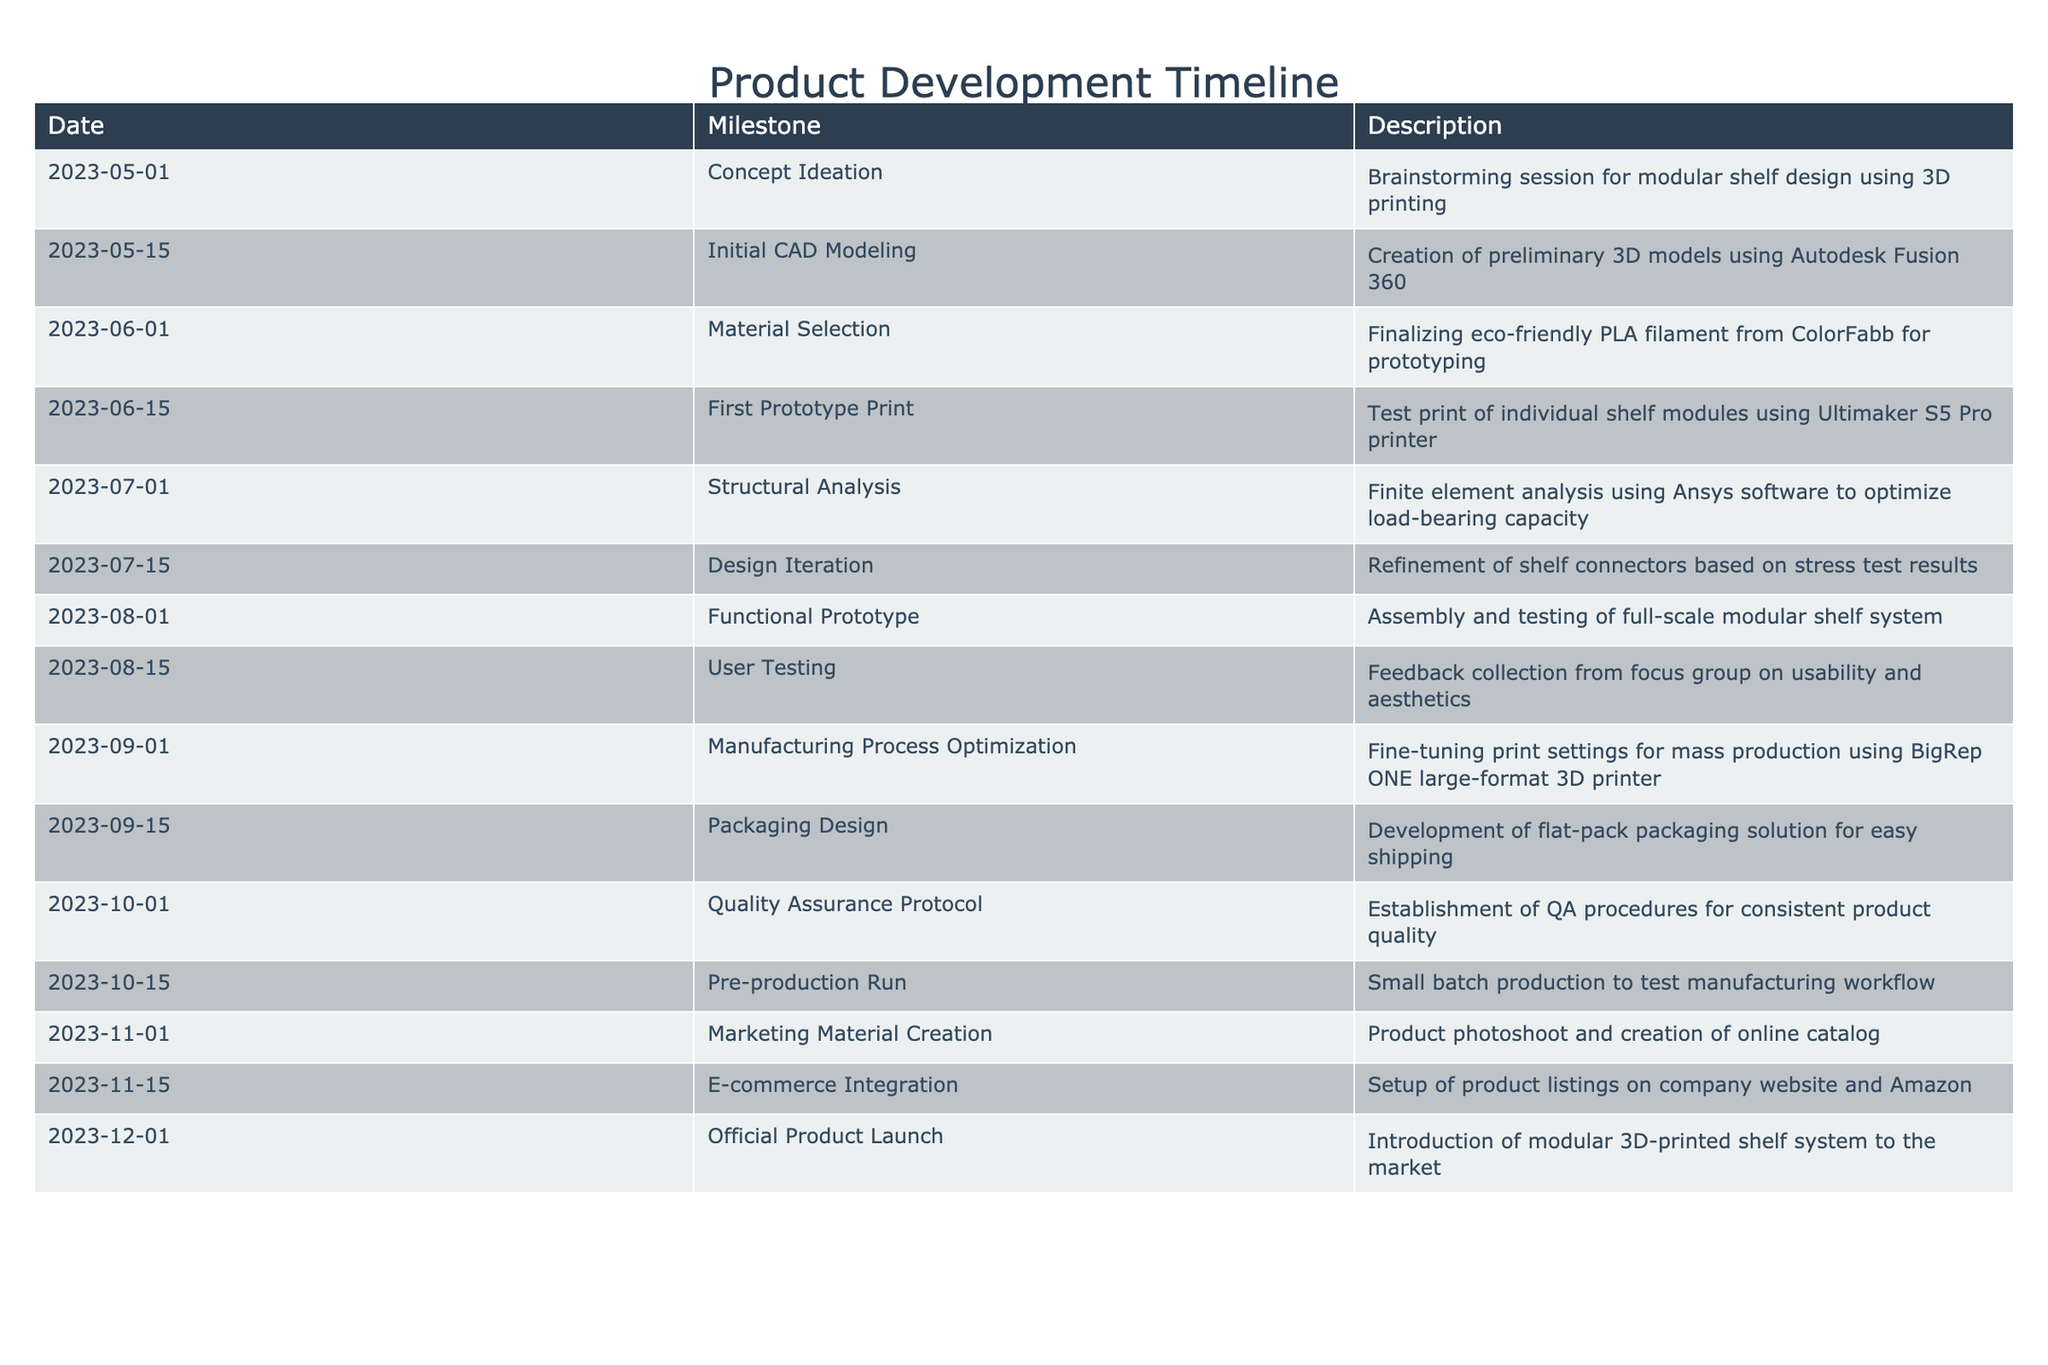What milestone occurred on 2023-07-01? The table indicates that on July 1, 2023, the milestone was "Structural Analysis," which involved conducting finite element analysis using Ansys software to optimize load-bearing capacity.
Answer: Structural Analysis How many milestones were completed before the user testing on 2023-08-15? To determine the number of milestones completed before user testing, we count each milestone listed prior to the date August 15, 2023. There are seven milestones listed before this date (up to Functional Prototype on 2023-08-01).
Answer: 7 Did the team finalize a material for the shelf design before creating the first prototype? The table shows that material selection was completed on June 1, 2023, and the first prototype was printed on June 15, 2023. Therefore, the material selection was finalized before the first prototype was created.
Answer: Yes What is the difference in time between the Initial CAD Modeling and the Official Product Launch? The Initial CAD Modeling was dated May 15, 2023, and the Official Product Launch was on December 1, 2023. The difference in days between these two dates is 199 days (from May 15 to December 1).
Answer: 199 days How many milestones involved testing or user feedback? We can identify from the table that user testing (August 15) and the functional prototype testing (August 1) are the milestones related to testing or user feedback. Therefore, there are two milestones involving testing or user feedback.
Answer: 2 Which month had the highest number of milestones? By reviewing the table, the month of October has three milestones (Quality Assurance Protocol on October 1, Pre-production Run on October 15, and Marketing Material Creation on November 1). No other month has more than three.
Answer: October What were the final two milestones listed in the product development timeline? The two final milestones noted in the table are "E-commerce Integration" on November 15, 2023, and "Official Product Launch" on December 1, 2023.
Answer: E-commerce Integration and Official Product Launch Was there a milestone dedicated to packaging design, and if so, when did it occur? The table clearly states that "Packaging Design" was established on September 15, 2023. Therefore, there was indeed a milestone dedicated to packaging design.
Answer: Yes, on September 15, 2023 